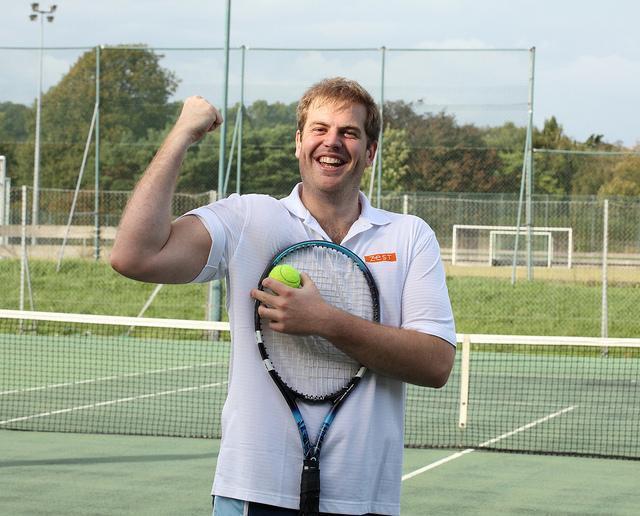What does the man show off here?
Make your selection and explain in format: 'Answer: answer
Rationale: rationale.'
Options: Racquet, tennis ball, shirt, bicep. Answer: bicep.
Rationale: The man has biceps. 